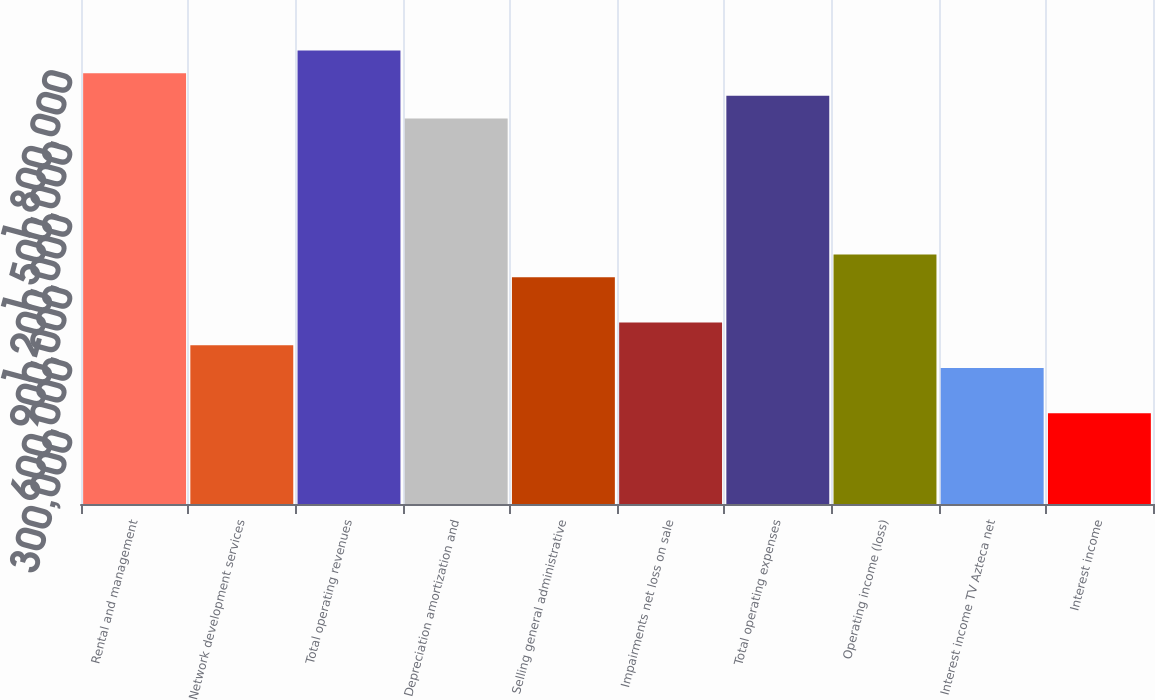Convert chart. <chart><loc_0><loc_0><loc_500><loc_500><bar_chart><fcel>Rental and management<fcel>Network development services<fcel>Total operating revenues<fcel>Depreciation amortization and<fcel>Selling general administrative<fcel>Impairments net loss on sale<fcel>Total operating expenses<fcel>Operating income (loss)<fcel>Interest income TV Azteca net<fcel>Interest income<nl><fcel>1.79509e+06<fcel>661350<fcel>1.88957e+06<fcel>1.60614e+06<fcel>944786<fcel>755829<fcel>1.70061e+06<fcel>1.03926e+06<fcel>566872<fcel>377915<nl></chart> 